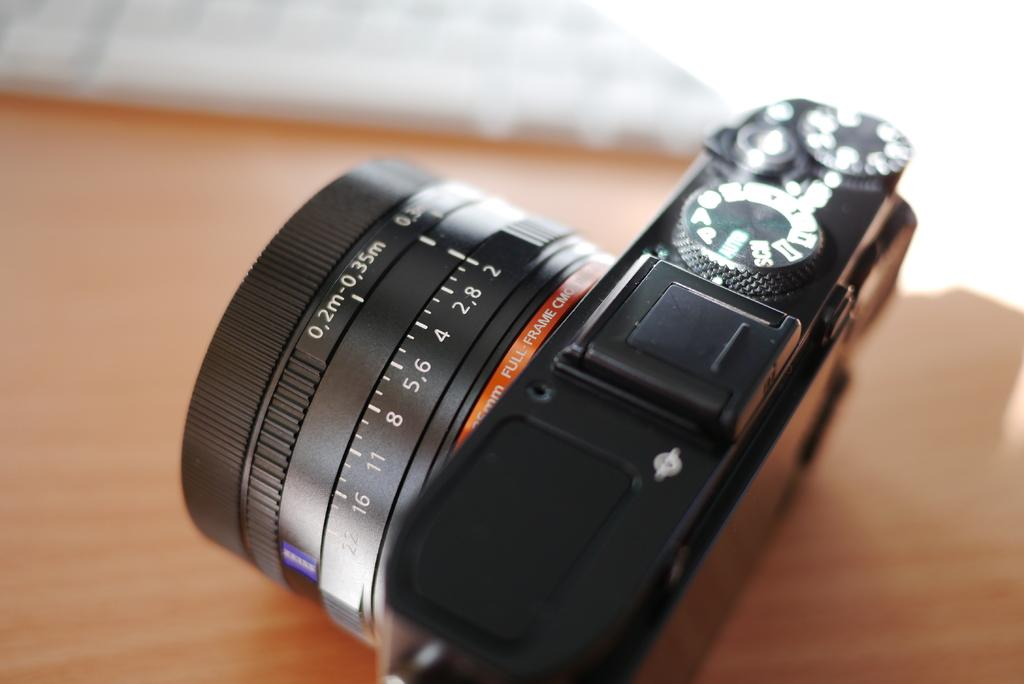Provide a one-sentence caption for the provided image. Black camera which has the measurement of 0.2m on it. 